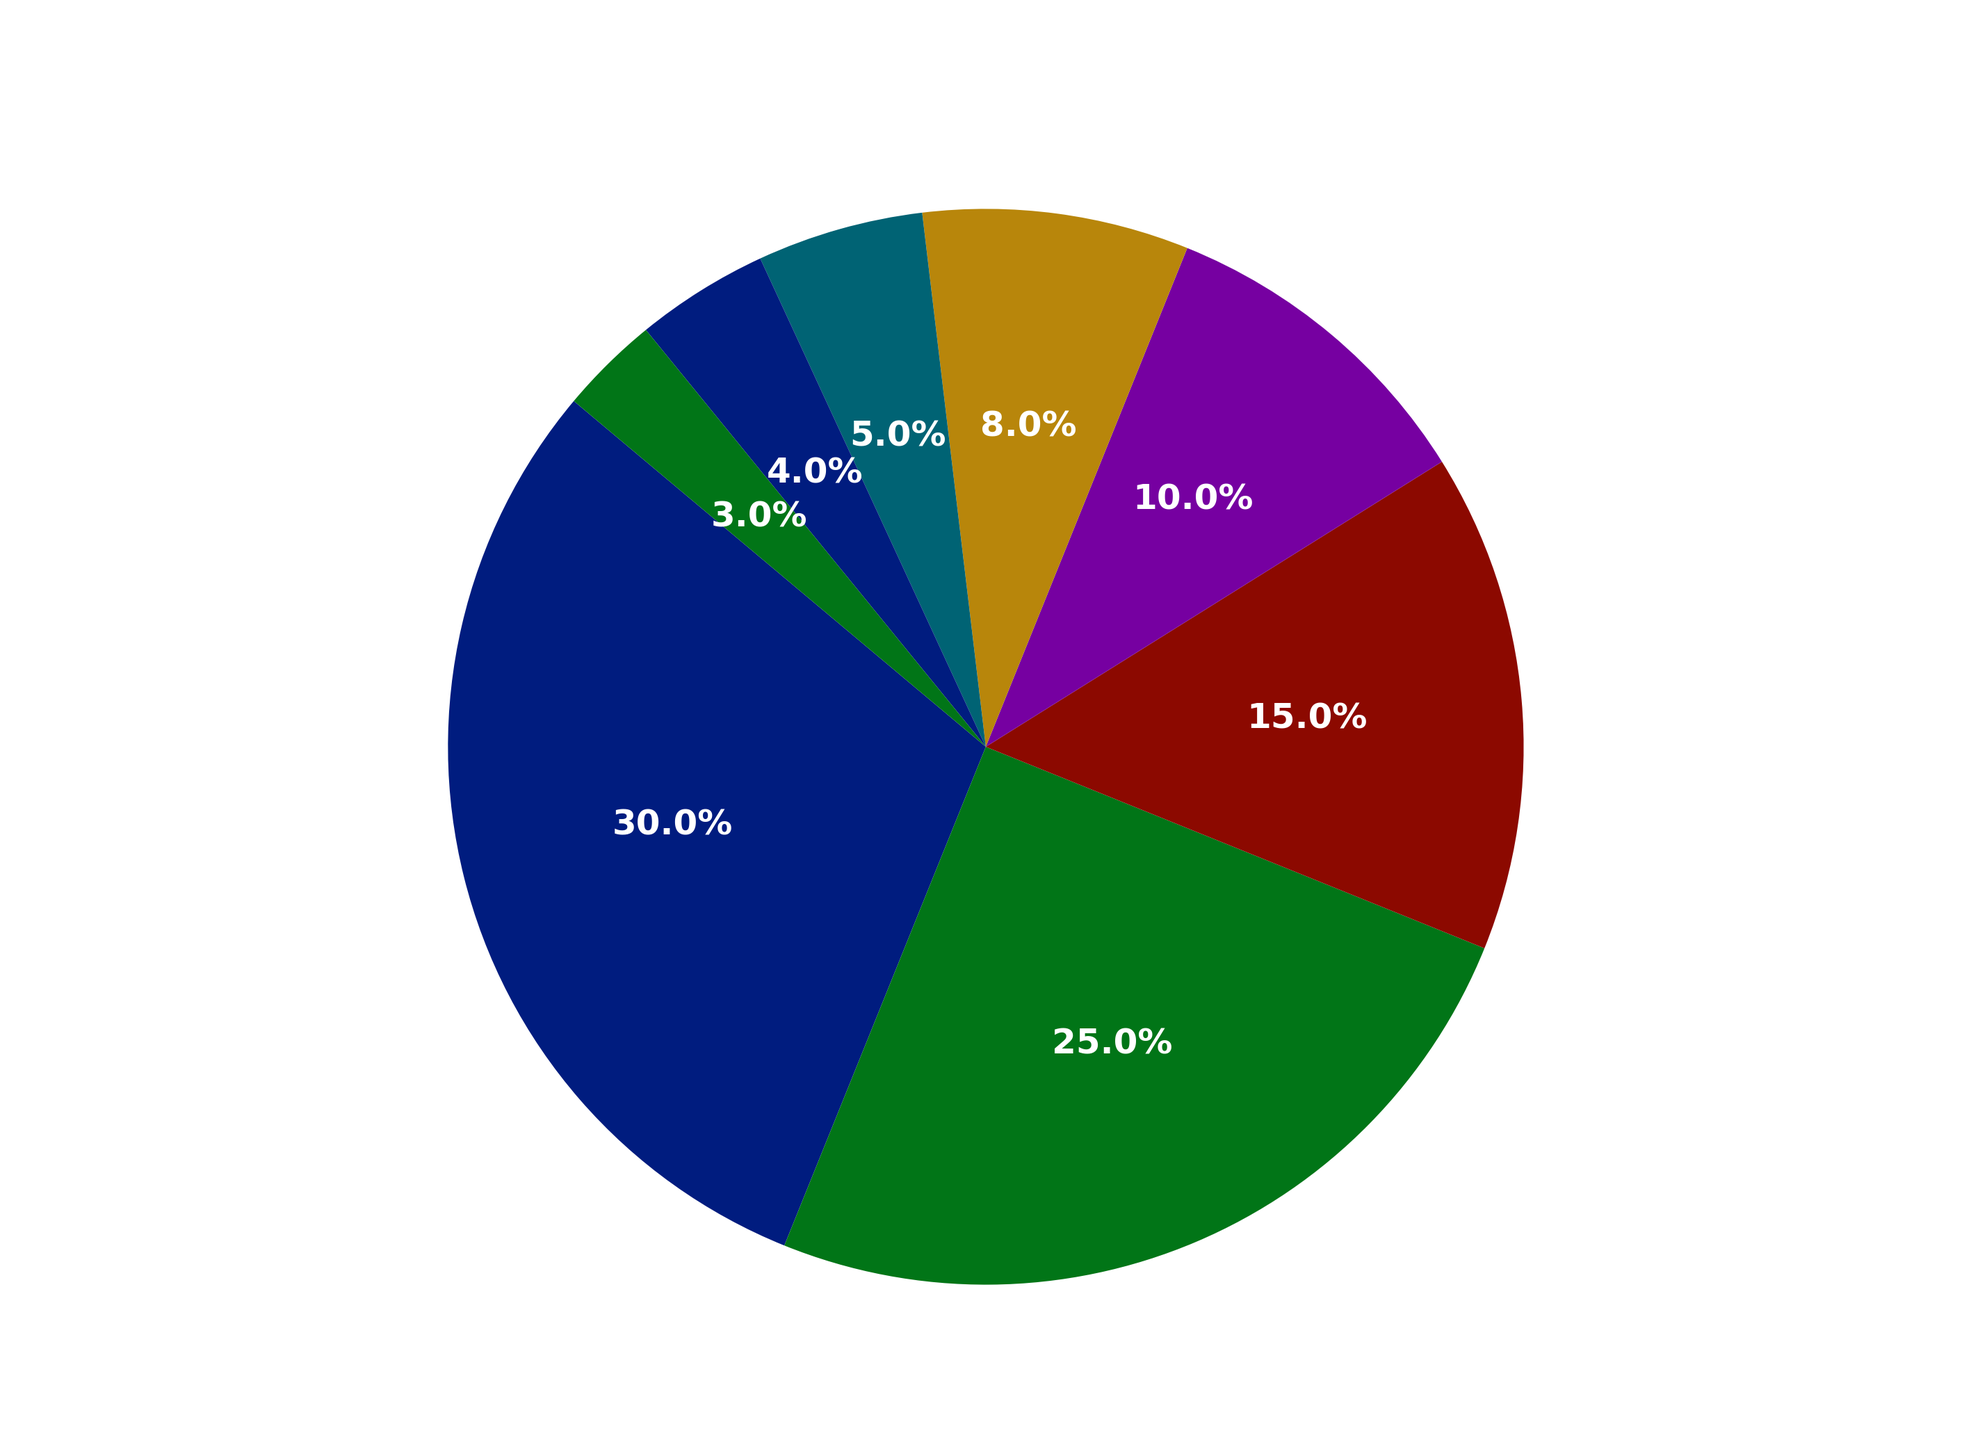What's the most commonly used painting medium? The figure shows different mediums with their corresponding percentages. The medium with the highest percentage is the most commonly used. According to the data, oil holds the highest percentage.
Answer: Oil Which medium comes right after oil in terms of popularity? Look at the second-largest segment in the pie chart. Oil is the first with 30%, and the next largest segment is acrylic with 25%.
Answer: Acrylic What is the combined percentage of digital and ink mediums? To find the combined percentage, you add the percentages of digital and ink. From the figure, digital is 10% and ink is 8%. Summing them up gives 10% + 8% = 18%.
Answer: 18% Are pastel and gouache usage percentages greater or less than watercolor? Compare the combined percentage of pastel and gouache with watercolor. Pastel is 4% and gouache is 5%, summing up to 9%. Watercolor is 15%. Since 9% < 15%, pastel and gouache combined are less than watercolor.
Answer: Less Which mediums have less usage than ink? Find all segments with a percentage lower than ink's 8%. Gouache (5%), pastel (4%), and other (3%) are the mediums with less usage than ink.
Answer: Gouache, Pastel, Other By how much does oil surpass acrylic in terms of percentage? Subtract the percentage of acrylic from the percentage of oil. Oil is at 30% and acrylic is at 25%. Thus, 30% - 25% gives a difference of 5%.
Answer: 5% What's the total percentage for non-traditional (digital and other) mediums? Add the percentages for digital and other mediums. Digital is 10% and other is 3%, giving a total of 10% + 3% = 13%.
Answer: 13% What is the percentage difference between the least used medium and the most used medium? Subtract the percentage of the least used medium from the percentage of the most used medium. Oil is 30% and other is 3%, so 30% - 3% = 27%.
Answer: 27% Combine the percentages of all non-digital mediums. What is the result? Subtract the percentage of the digital medium from the total (100%). Digital is 10%, so 100% - 10% = 90%.
Answer: 90% Which mediums have usage between 5% and 15%? Identify the segments that fall between these percentages. Watercolor (15%), ink (8%), and gouache (5%) fall in the range.
Answer: Watercolor, Ink, Gouache 